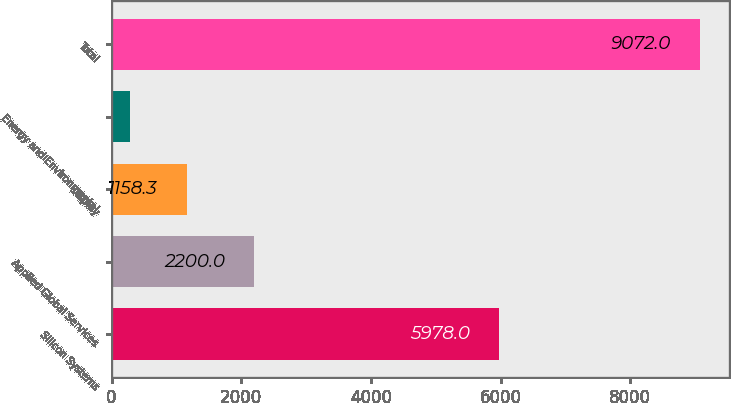Convert chart to OTSL. <chart><loc_0><loc_0><loc_500><loc_500><bar_chart><fcel>Silicon Systems<fcel>Applied Global Services<fcel>Display<fcel>Energy and Environmental<fcel>Total<nl><fcel>5978<fcel>2200<fcel>1158.3<fcel>279<fcel>9072<nl></chart> 